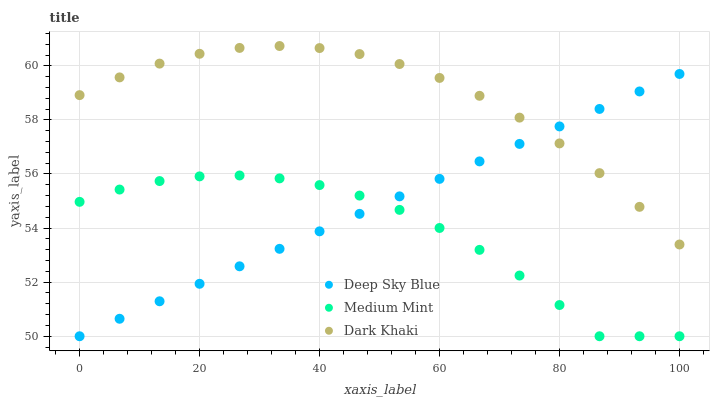Does Medium Mint have the minimum area under the curve?
Answer yes or no. Yes. Does Dark Khaki have the maximum area under the curve?
Answer yes or no. Yes. Does Deep Sky Blue have the minimum area under the curve?
Answer yes or no. No. Does Deep Sky Blue have the maximum area under the curve?
Answer yes or no. No. Is Deep Sky Blue the smoothest?
Answer yes or no. Yes. Is Medium Mint the roughest?
Answer yes or no. Yes. Is Dark Khaki the smoothest?
Answer yes or no. No. Is Dark Khaki the roughest?
Answer yes or no. No. Does Medium Mint have the lowest value?
Answer yes or no. Yes. Does Dark Khaki have the lowest value?
Answer yes or no. No. Does Dark Khaki have the highest value?
Answer yes or no. Yes. Does Deep Sky Blue have the highest value?
Answer yes or no. No. Is Medium Mint less than Dark Khaki?
Answer yes or no. Yes. Is Dark Khaki greater than Medium Mint?
Answer yes or no. Yes. Does Medium Mint intersect Deep Sky Blue?
Answer yes or no. Yes. Is Medium Mint less than Deep Sky Blue?
Answer yes or no. No. Is Medium Mint greater than Deep Sky Blue?
Answer yes or no. No. Does Medium Mint intersect Dark Khaki?
Answer yes or no. No. 